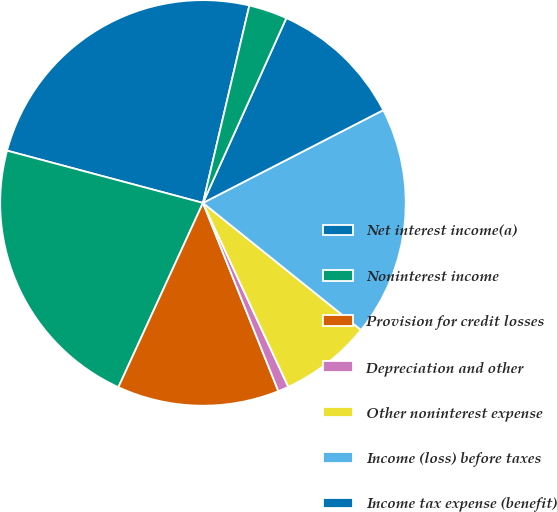<chart> <loc_0><loc_0><loc_500><loc_500><pie_chart><fcel>Net interest income(a)<fcel>Noninterest income<fcel>Provision for credit losses<fcel>Depreciation and other<fcel>Other noninterest expense<fcel>Income (loss) before taxes<fcel>Income tax expense (benefit)<fcel>Average total assets (in<nl><fcel>24.52%<fcel>22.3%<fcel>12.91%<fcel>0.85%<fcel>7.31%<fcel>18.34%<fcel>10.69%<fcel>3.07%<nl></chart> 